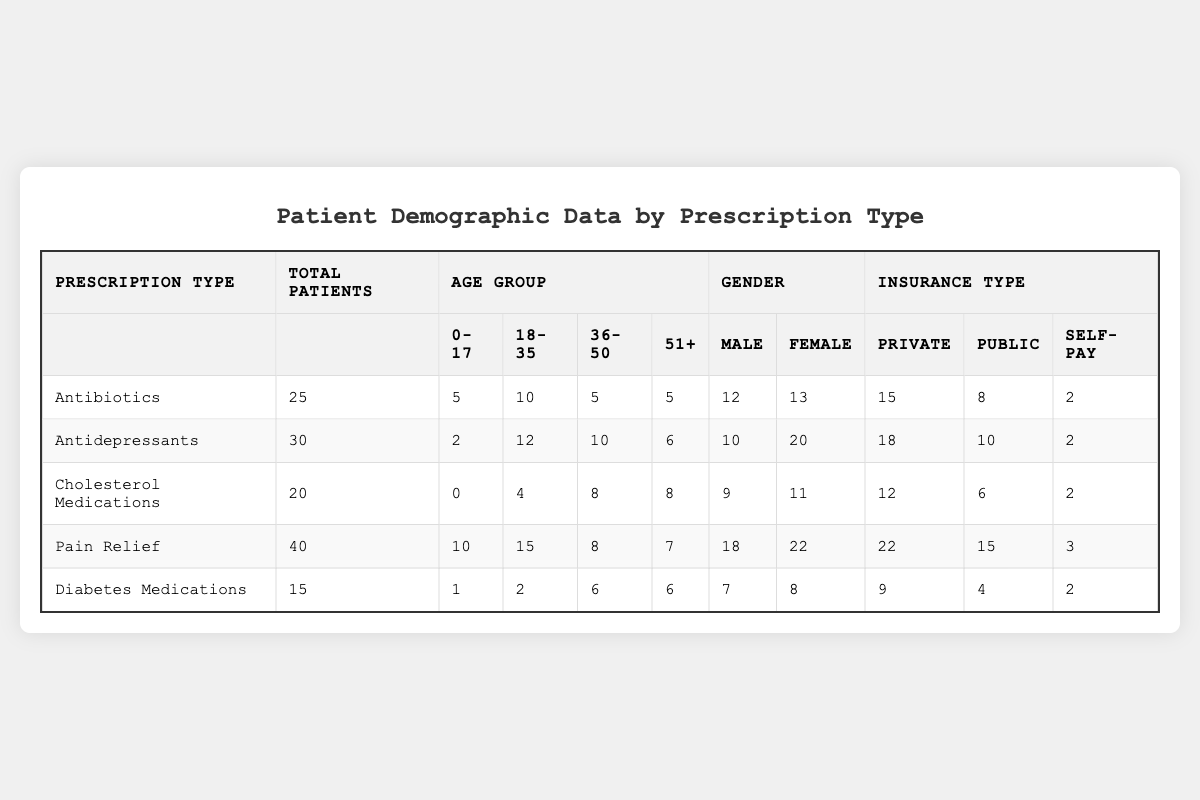What is the total number of patients prescribed Pain Relief? Directly refer to the table under the "Total Patients" column for Pain Relief, which shows 40 patients.
Answer: 40 How many females are prescribed Antidepressants? Look at the "Gender" section for Antidepressants, which indicates 20 females.
Answer: 20 What is the age group with the most patients in Cholesterol Medications? Examine the "Age Group" section, where the "36-50" and "51+" age groups both have 8 patients, but the 36-50 is counted first in the presentation.
Answer: 36-50 (8 patients) Which prescription type has the highest percentage of self-pay patients? Analyze the "Self-Pay" column for each prescription type. Pain Relief has 3 self-pay patients out of 40 total, giving 7.5%. Compare this to others to conclude.
Answer: Pain Relief (7.5%) What is the average number of patients across all prescription types? Sum the total patients across all types (25 + 30 + 20 + 40 + 15 = 130) and divide by the number of prescription types (5). The average is 130/5 = 26.
Answer: 26 Is the number of males higher than females in the Diabetes Medications group? The table indicates 7 males and 8 females under Diabetes Medications, which shows that there are fewer males than females.
Answer: No What is the difference between the total number of private insurance patients in Pain Relief and Antibiotics? Count the private insurance patients for Pain Relief (22) and Antibiotics (15), then find the difference: 22 - 15 = 7.
Answer: 7 Which age group has the least number of patients prescribed Antibiotics? Refer to the "Age Group" section under Antibiotics; both the "0-17" and "51+" groups have 5 patients, showing it's a tie for the least.
Answer: 0-17 and 51+ (5 each) Considering all prescription types, what percentage of total patients is on Diabetes Medications? Total patients across all types is 130, with 15 being for Diabetes Medications. The calculation is (15/130)*100, which equals approximately 11.54%.
Answer: 11.54% Is there a prescription type where the number of males exceeds the total patients in the 0-17 age group? Look at the total males in each prescription type. For example, Pain Relief has 18 males while the 0-17 group for Pain Relief has 10 patients. Yes, this is true.
Answer: Yes 